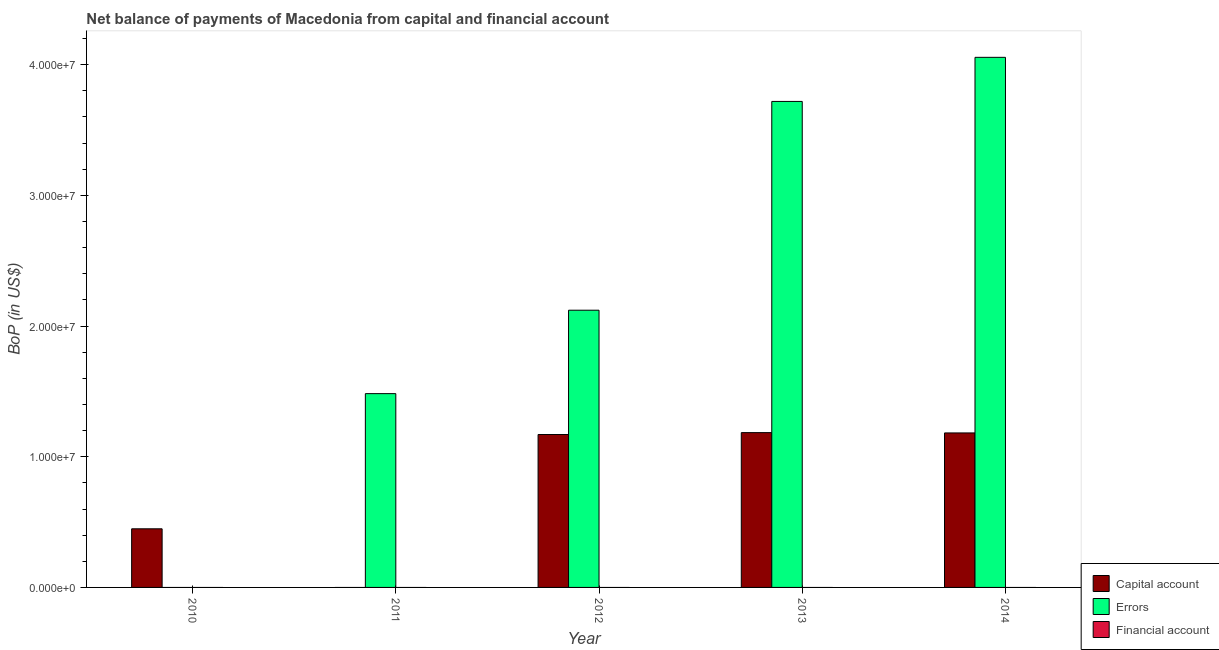How many different coloured bars are there?
Keep it short and to the point. 2. How many bars are there on the 4th tick from the left?
Offer a very short reply. 2. How many bars are there on the 3rd tick from the right?
Offer a very short reply. 2. In how many cases, is the number of bars for a given year not equal to the number of legend labels?
Your answer should be compact. 5. Across all years, what is the maximum amount of errors?
Offer a very short reply. 4.06e+07. In which year was the amount of errors maximum?
Your answer should be compact. 2014. What is the total amount of errors in the graph?
Offer a terse response. 1.14e+08. What is the difference between the amount of errors in 2011 and that in 2013?
Give a very brief answer. -2.24e+07. What is the difference between the amount of errors in 2011 and the amount of net capital account in 2014?
Offer a terse response. -2.57e+07. What is the average amount of errors per year?
Your answer should be very brief. 2.28e+07. What is the ratio of the amount of net capital account in 2010 to that in 2012?
Give a very brief answer. 0.38. Is the amount of net capital account in 2013 less than that in 2014?
Your answer should be very brief. No. What is the difference between the highest and the second highest amount of net capital account?
Provide a short and direct response. 2.45e+04. What is the difference between the highest and the lowest amount of net capital account?
Offer a terse response. 1.18e+07. Is the sum of the amount of net capital account in 2010 and 2012 greater than the maximum amount of financial account across all years?
Provide a succinct answer. Yes. Is it the case that in every year, the sum of the amount of net capital account and amount of errors is greater than the amount of financial account?
Your answer should be compact. Yes. How many bars are there?
Your response must be concise. 8. How many years are there in the graph?
Ensure brevity in your answer.  5. What is the difference between two consecutive major ticks on the Y-axis?
Your response must be concise. 1.00e+07. Does the graph contain any zero values?
Your answer should be very brief. Yes. Does the graph contain grids?
Your answer should be very brief. No. How are the legend labels stacked?
Offer a very short reply. Vertical. What is the title of the graph?
Your response must be concise. Net balance of payments of Macedonia from capital and financial account. What is the label or title of the X-axis?
Give a very brief answer. Year. What is the label or title of the Y-axis?
Ensure brevity in your answer.  BoP (in US$). What is the BoP (in US$) in Capital account in 2010?
Offer a terse response. 4.49e+06. What is the BoP (in US$) of Errors in 2010?
Offer a very short reply. 0. What is the BoP (in US$) of Capital account in 2011?
Make the answer very short. 0. What is the BoP (in US$) of Errors in 2011?
Provide a succinct answer. 1.48e+07. What is the BoP (in US$) in Capital account in 2012?
Offer a terse response. 1.17e+07. What is the BoP (in US$) in Errors in 2012?
Provide a short and direct response. 2.12e+07. What is the BoP (in US$) in Capital account in 2013?
Keep it short and to the point. 1.18e+07. What is the BoP (in US$) in Errors in 2013?
Provide a short and direct response. 3.72e+07. What is the BoP (in US$) of Capital account in 2014?
Offer a terse response. 1.18e+07. What is the BoP (in US$) in Errors in 2014?
Ensure brevity in your answer.  4.06e+07. Across all years, what is the maximum BoP (in US$) of Capital account?
Provide a short and direct response. 1.18e+07. Across all years, what is the maximum BoP (in US$) in Errors?
Your response must be concise. 4.06e+07. Across all years, what is the minimum BoP (in US$) in Capital account?
Offer a very short reply. 0. Across all years, what is the minimum BoP (in US$) in Errors?
Ensure brevity in your answer.  0. What is the total BoP (in US$) in Capital account in the graph?
Provide a short and direct response. 3.99e+07. What is the total BoP (in US$) in Errors in the graph?
Provide a short and direct response. 1.14e+08. What is the total BoP (in US$) of Financial account in the graph?
Your answer should be very brief. 0. What is the difference between the BoP (in US$) of Capital account in 2010 and that in 2012?
Give a very brief answer. -7.22e+06. What is the difference between the BoP (in US$) in Capital account in 2010 and that in 2013?
Offer a very short reply. -7.36e+06. What is the difference between the BoP (in US$) of Capital account in 2010 and that in 2014?
Offer a terse response. -7.34e+06. What is the difference between the BoP (in US$) of Errors in 2011 and that in 2012?
Ensure brevity in your answer.  -6.38e+06. What is the difference between the BoP (in US$) of Errors in 2011 and that in 2013?
Your response must be concise. -2.24e+07. What is the difference between the BoP (in US$) in Errors in 2011 and that in 2014?
Provide a short and direct response. -2.57e+07. What is the difference between the BoP (in US$) in Capital account in 2012 and that in 2013?
Make the answer very short. -1.45e+05. What is the difference between the BoP (in US$) in Errors in 2012 and that in 2013?
Offer a very short reply. -1.60e+07. What is the difference between the BoP (in US$) of Capital account in 2012 and that in 2014?
Provide a short and direct response. -1.21e+05. What is the difference between the BoP (in US$) of Errors in 2012 and that in 2014?
Offer a very short reply. -1.94e+07. What is the difference between the BoP (in US$) of Capital account in 2013 and that in 2014?
Your response must be concise. 2.45e+04. What is the difference between the BoP (in US$) of Errors in 2013 and that in 2014?
Your response must be concise. -3.37e+06. What is the difference between the BoP (in US$) in Capital account in 2010 and the BoP (in US$) in Errors in 2011?
Your response must be concise. -1.03e+07. What is the difference between the BoP (in US$) in Capital account in 2010 and the BoP (in US$) in Errors in 2012?
Your response must be concise. -1.67e+07. What is the difference between the BoP (in US$) of Capital account in 2010 and the BoP (in US$) of Errors in 2013?
Ensure brevity in your answer.  -3.27e+07. What is the difference between the BoP (in US$) in Capital account in 2010 and the BoP (in US$) in Errors in 2014?
Keep it short and to the point. -3.61e+07. What is the difference between the BoP (in US$) of Capital account in 2012 and the BoP (in US$) of Errors in 2013?
Provide a short and direct response. -2.55e+07. What is the difference between the BoP (in US$) of Capital account in 2012 and the BoP (in US$) of Errors in 2014?
Keep it short and to the point. -2.89e+07. What is the difference between the BoP (in US$) of Capital account in 2013 and the BoP (in US$) of Errors in 2014?
Give a very brief answer. -2.87e+07. What is the average BoP (in US$) in Capital account per year?
Offer a very short reply. 7.97e+06. What is the average BoP (in US$) of Errors per year?
Your response must be concise. 2.28e+07. In the year 2012, what is the difference between the BoP (in US$) of Capital account and BoP (in US$) of Errors?
Keep it short and to the point. -9.51e+06. In the year 2013, what is the difference between the BoP (in US$) of Capital account and BoP (in US$) of Errors?
Your answer should be compact. -2.53e+07. In the year 2014, what is the difference between the BoP (in US$) in Capital account and BoP (in US$) in Errors?
Provide a succinct answer. -2.87e+07. What is the ratio of the BoP (in US$) of Capital account in 2010 to that in 2012?
Your answer should be compact. 0.38. What is the ratio of the BoP (in US$) of Capital account in 2010 to that in 2013?
Make the answer very short. 0.38. What is the ratio of the BoP (in US$) in Capital account in 2010 to that in 2014?
Provide a short and direct response. 0.38. What is the ratio of the BoP (in US$) of Errors in 2011 to that in 2012?
Provide a succinct answer. 0.7. What is the ratio of the BoP (in US$) of Errors in 2011 to that in 2013?
Make the answer very short. 0.4. What is the ratio of the BoP (in US$) in Errors in 2011 to that in 2014?
Keep it short and to the point. 0.37. What is the ratio of the BoP (in US$) in Errors in 2012 to that in 2013?
Offer a very short reply. 0.57. What is the ratio of the BoP (in US$) in Errors in 2012 to that in 2014?
Offer a terse response. 0.52. What is the ratio of the BoP (in US$) in Capital account in 2013 to that in 2014?
Your answer should be very brief. 1. What is the ratio of the BoP (in US$) in Errors in 2013 to that in 2014?
Offer a terse response. 0.92. What is the difference between the highest and the second highest BoP (in US$) in Capital account?
Your response must be concise. 2.45e+04. What is the difference between the highest and the second highest BoP (in US$) of Errors?
Make the answer very short. 3.37e+06. What is the difference between the highest and the lowest BoP (in US$) in Capital account?
Offer a very short reply. 1.18e+07. What is the difference between the highest and the lowest BoP (in US$) in Errors?
Offer a terse response. 4.06e+07. 